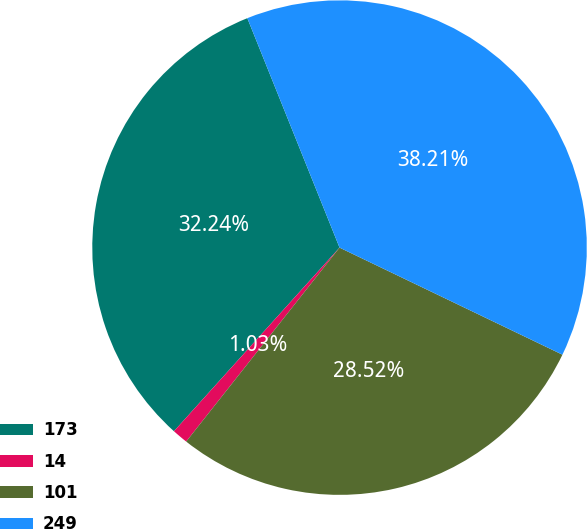Convert chart to OTSL. <chart><loc_0><loc_0><loc_500><loc_500><pie_chart><fcel>173<fcel>14<fcel>101<fcel>249<nl><fcel>32.24%<fcel>1.03%<fcel>28.52%<fcel>38.21%<nl></chart> 